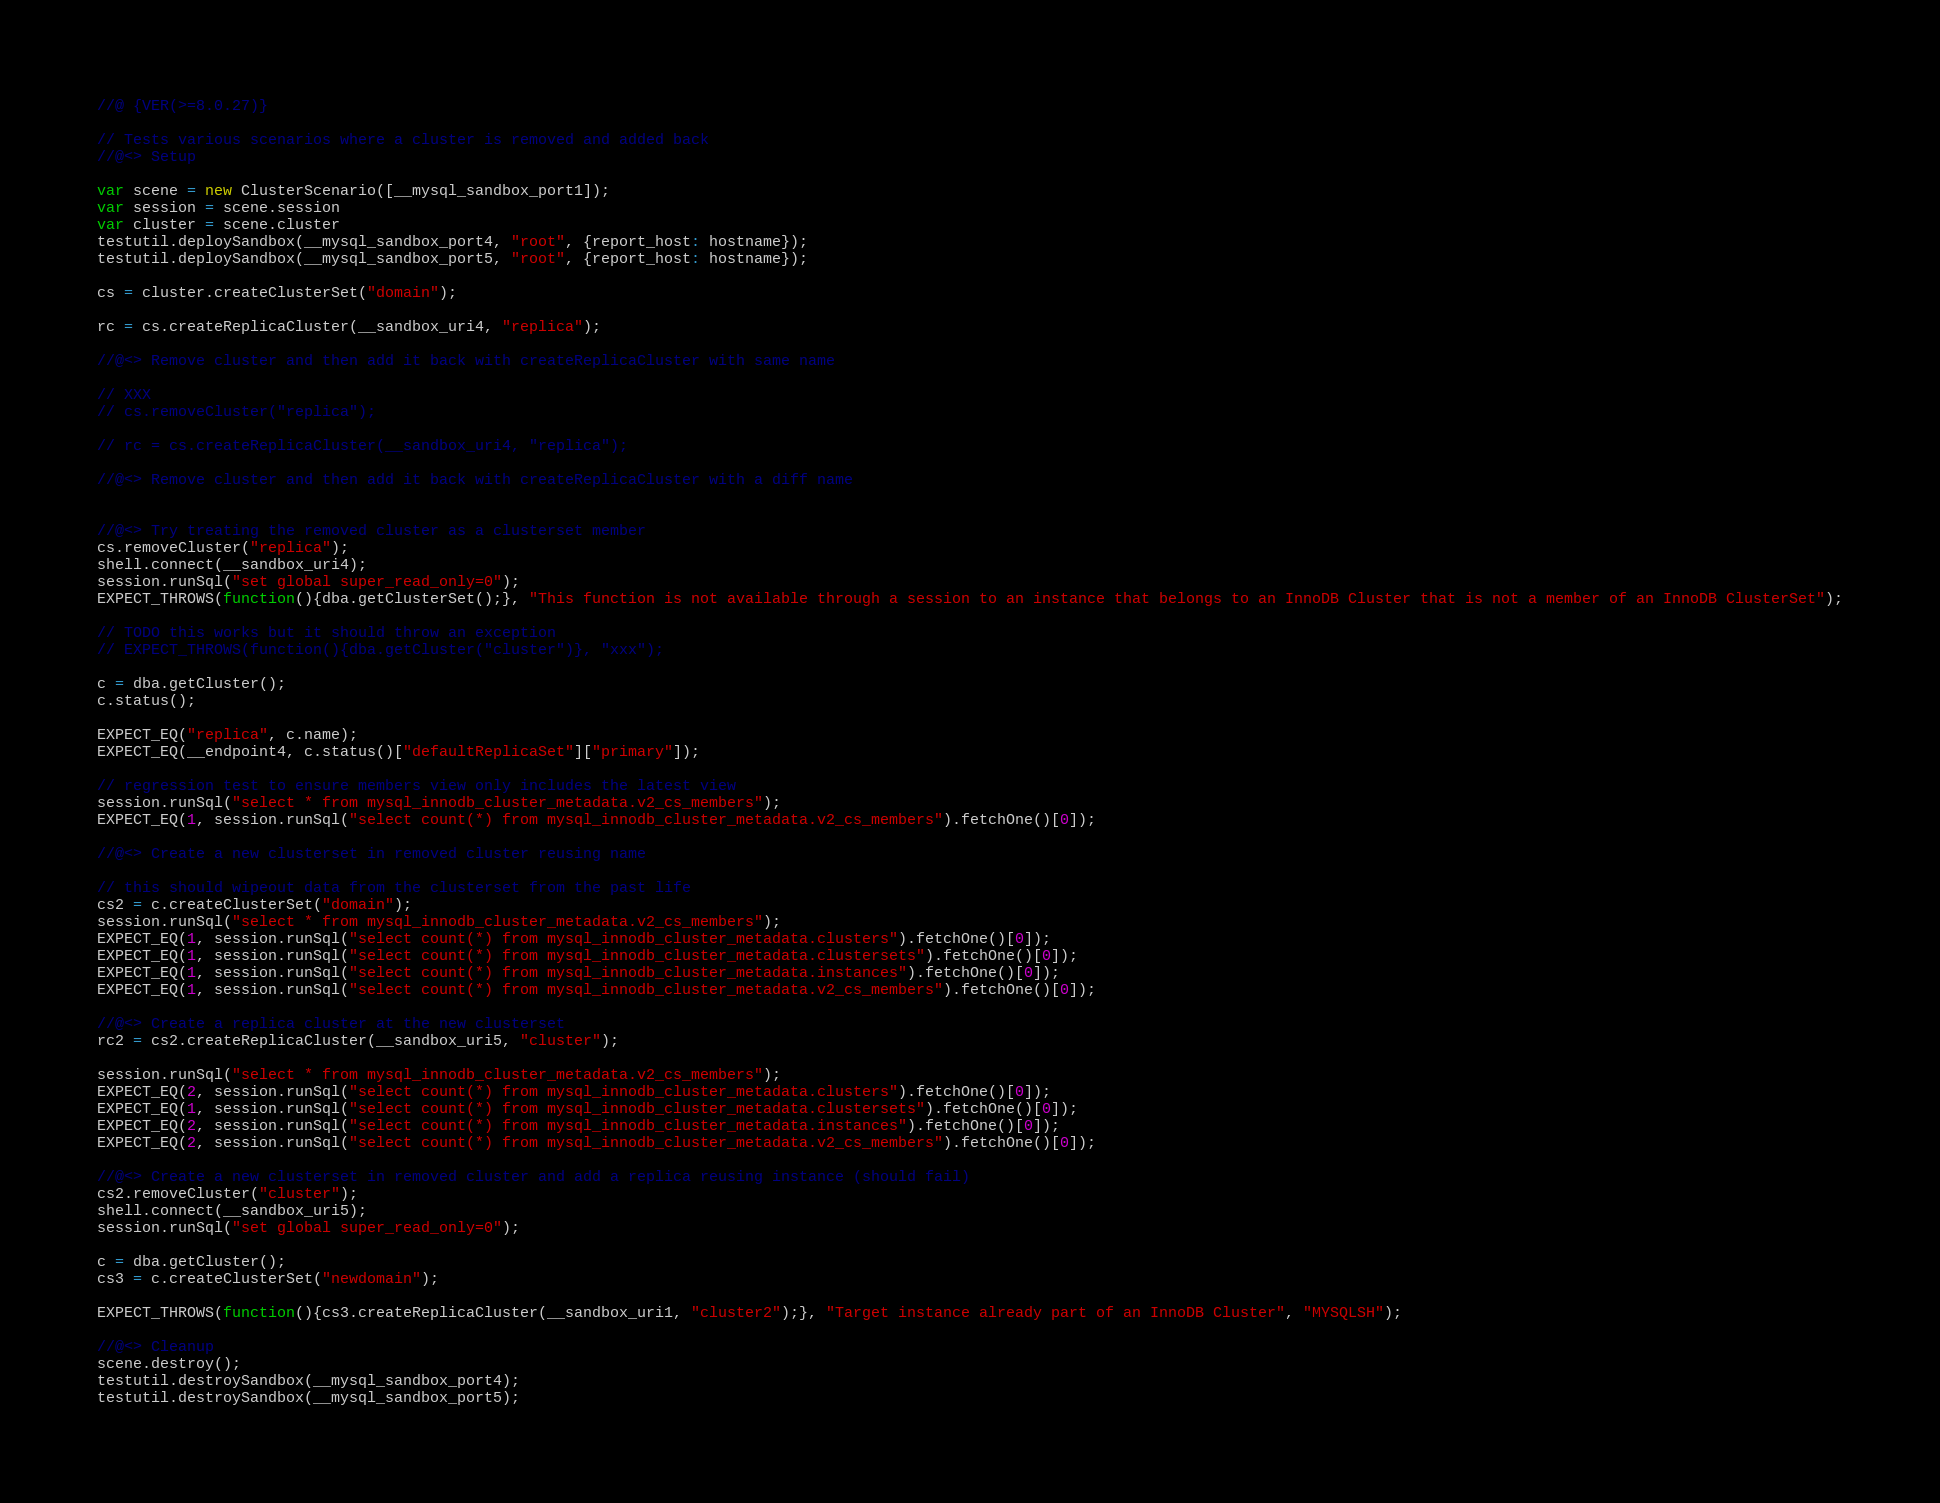<code> <loc_0><loc_0><loc_500><loc_500><_JavaScript_>//@ {VER(>=8.0.27)}

// Tests various scenarios where a cluster is removed and added back
//@<> Setup

var scene = new ClusterScenario([__mysql_sandbox_port1]);
var session = scene.session
var cluster = scene.cluster
testutil.deploySandbox(__mysql_sandbox_port4, "root", {report_host: hostname});
testutil.deploySandbox(__mysql_sandbox_port5, "root", {report_host: hostname});

cs = cluster.createClusterSet("domain");

rc = cs.createReplicaCluster(__sandbox_uri4, "replica");

//@<> Remove cluster and then add it back with createReplicaCluster with same name

// XXX
// cs.removeCluster("replica");

// rc = cs.createReplicaCluster(__sandbox_uri4, "replica");

//@<> Remove cluster and then add it back with createReplicaCluster with a diff name


//@<> Try treating the removed cluster as a clusterset member
cs.removeCluster("replica");
shell.connect(__sandbox_uri4);
session.runSql("set global super_read_only=0");
EXPECT_THROWS(function(){dba.getClusterSet();}, "This function is not available through a session to an instance that belongs to an InnoDB Cluster that is not a member of an InnoDB ClusterSet");

// TODO this works but it should throw an exception
// EXPECT_THROWS(function(){dba.getCluster("cluster")}, "xxx");

c = dba.getCluster();
c.status();

EXPECT_EQ("replica", c.name);
EXPECT_EQ(__endpoint4, c.status()["defaultReplicaSet"]["primary"]);

// regression test to ensure members view only includes the latest view
session.runSql("select * from mysql_innodb_cluster_metadata.v2_cs_members");
EXPECT_EQ(1, session.runSql("select count(*) from mysql_innodb_cluster_metadata.v2_cs_members").fetchOne()[0]);

//@<> Create a new clusterset in removed cluster reusing name

// this should wipeout data from the clusterset from the past life
cs2 = c.createClusterSet("domain");
session.runSql("select * from mysql_innodb_cluster_metadata.v2_cs_members");
EXPECT_EQ(1, session.runSql("select count(*) from mysql_innodb_cluster_metadata.clusters").fetchOne()[0]);
EXPECT_EQ(1, session.runSql("select count(*) from mysql_innodb_cluster_metadata.clustersets").fetchOne()[0]);
EXPECT_EQ(1, session.runSql("select count(*) from mysql_innodb_cluster_metadata.instances").fetchOne()[0]);
EXPECT_EQ(1, session.runSql("select count(*) from mysql_innodb_cluster_metadata.v2_cs_members").fetchOne()[0]);

//@<> Create a replica cluster at the new clusterset
rc2 = cs2.createReplicaCluster(__sandbox_uri5, "cluster");

session.runSql("select * from mysql_innodb_cluster_metadata.v2_cs_members");
EXPECT_EQ(2, session.runSql("select count(*) from mysql_innodb_cluster_metadata.clusters").fetchOne()[0]);
EXPECT_EQ(1, session.runSql("select count(*) from mysql_innodb_cluster_metadata.clustersets").fetchOne()[0]);
EXPECT_EQ(2, session.runSql("select count(*) from mysql_innodb_cluster_metadata.instances").fetchOne()[0]);
EXPECT_EQ(2, session.runSql("select count(*) from mysql_innodb_cluster_metadata.v2_cs_members").fetchOne()[0]);

//@<> Create a new clusterset in removed cluster and add a replica reusing instance (should fail)
cs2.removeCluster("cluster");
shell.connect(__sandbox_uri5);
session.runSql("set global super_read_only=0");

c = dba.getCluster();
cs3 = c.createClusterSet("newdomain");

EXPECT_THROWS(function(){cs3.createReplicaCluster(__sandbox_uri1, "cluster2");}, "Target instance already part of an InnoDB Cluster", "MYSQLSH");

//@<> Cleanup
scene.destroy();
testutil.destroySandbox(__mysql_sandbox_port4);
testutil.destroySandbox(__mysql_sandbox_port5);
</code> 